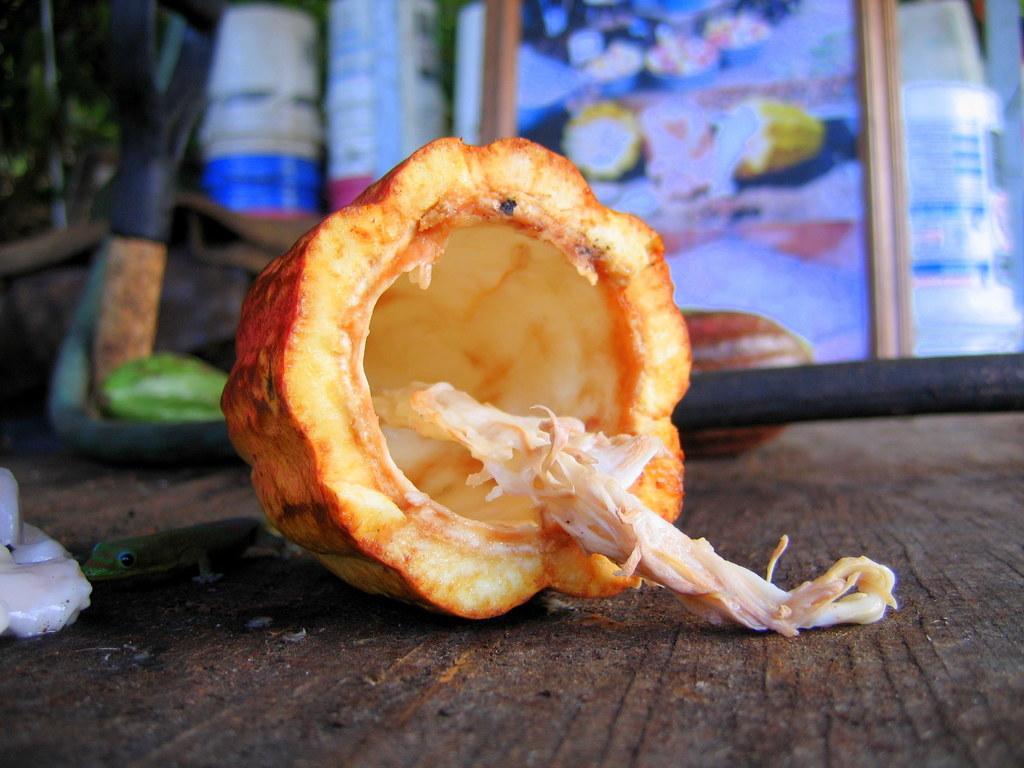Could you give a brief overview of what you see in this image? In this picture, it seems like a vegetable in the center of the image and the background is blurry. 